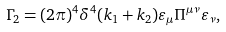<formula> <loc_0><loc_0><loc_500><loc_500>\Gamma _ { 2 } = ( 2 \pi ) ^ { 4 } \delta ^ { 4 } ( k _ { 1 } + k _ { 2 } ) \varepsilon _ { \mu } \Pi ^ { \mu \nu } \varepsilon _ { \nu } ,</formula> 